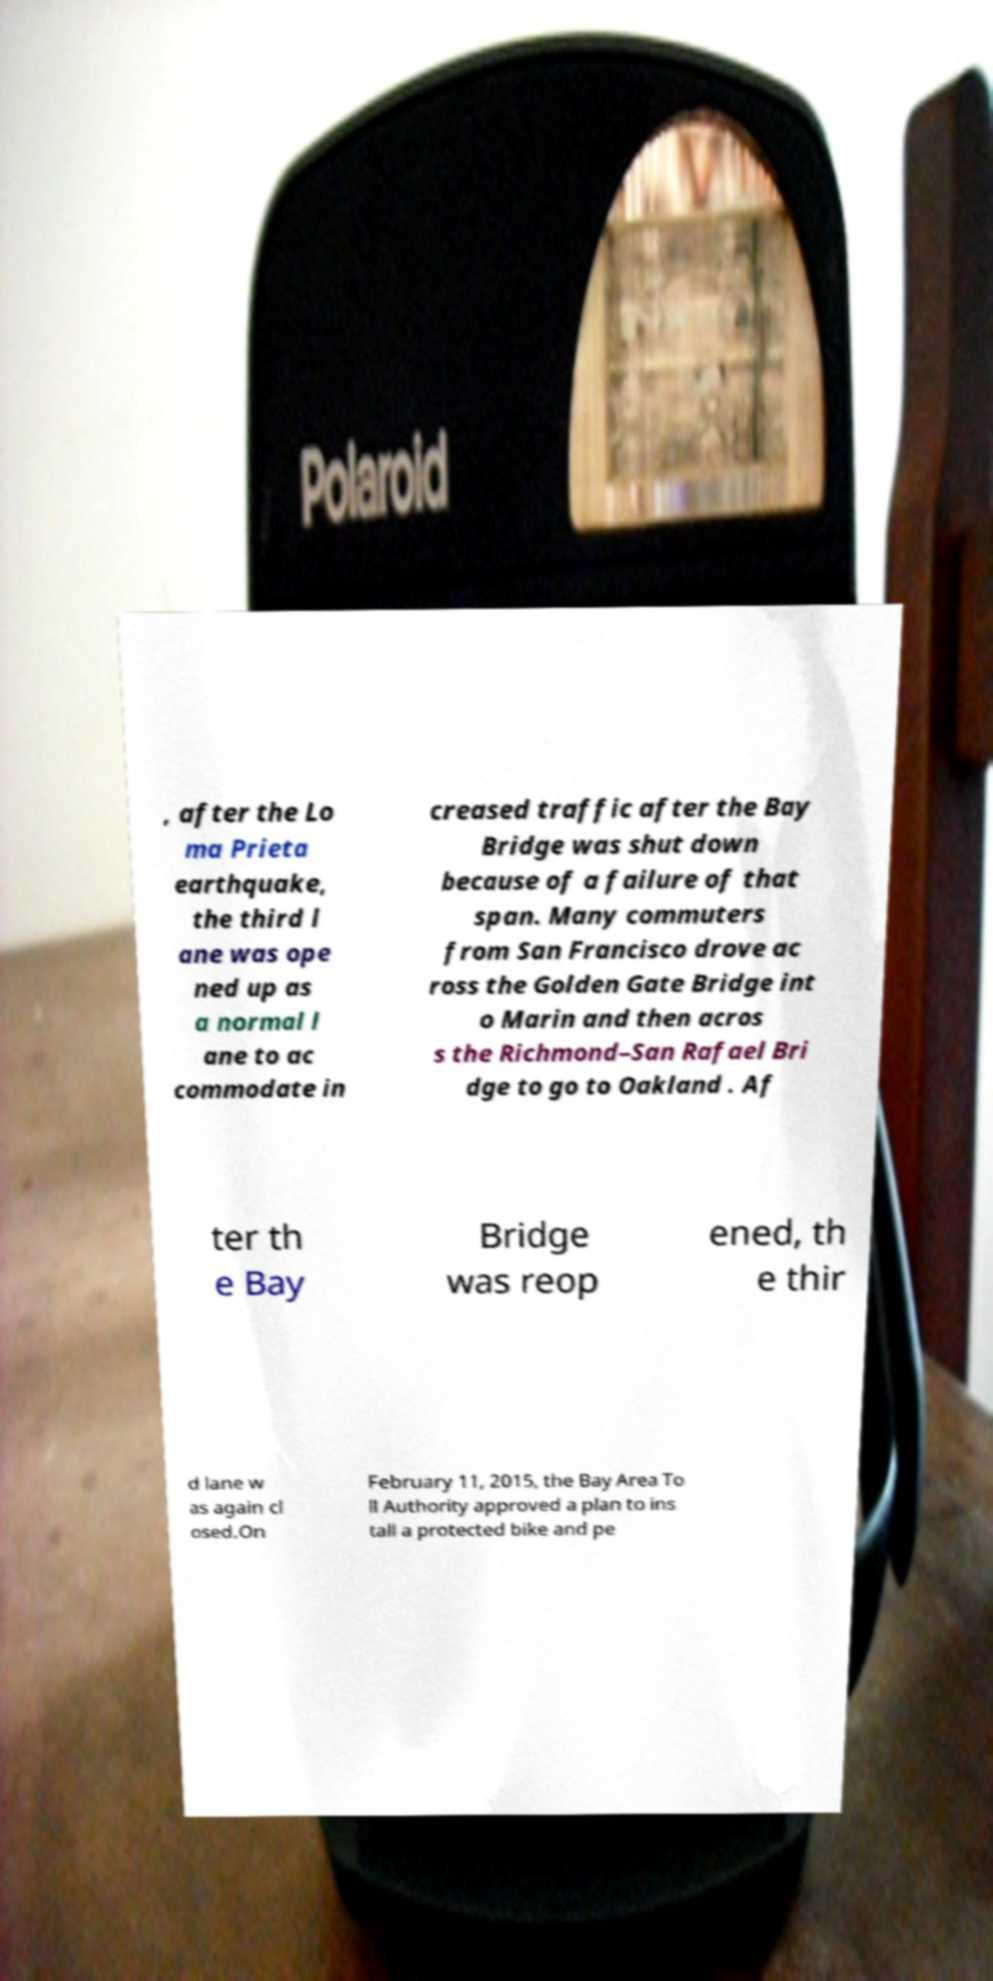Please read and relay the text visible in this image. What does it say? , after the Lo ma Prieta earthquake, the third l ane was ope ned up as a normal l ane to ac commodate in creased traffic after the Bay Bridge was shut down because of a failure of that span. Many commuters from San Francisco drove ac ross the Golden Gate Bridge int o Marin and then acros s the Richmond–San Rafael Bri dge to go to Oakland . Af ter th e Bay Bridge was reop ened, th e thir d lane w as again cl osed.On February 11, 2015, the Bay Area To ll Authority approved a plan to ins tall a protected bike and pe 